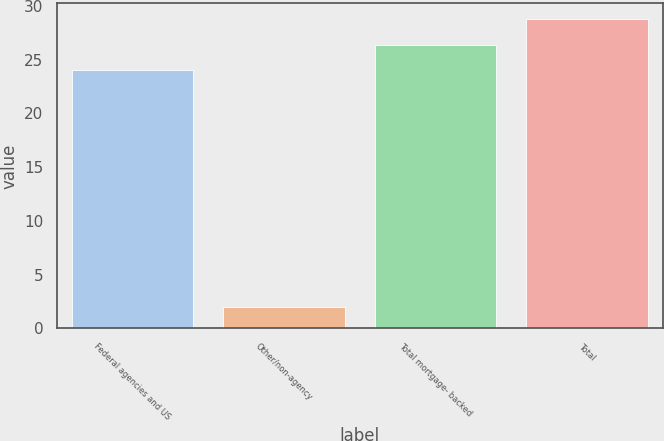<chart> <loc_0><loc_0><loc_500><loc_500><bar_chart><fcel>Federal agencies and US<fcel>Other/non-agency<fcel>Total mortgage- backed<fcel>Total<nl><fcel>24<fcel>2<fcel>26.4<fcel>28.8<nl></chart> 